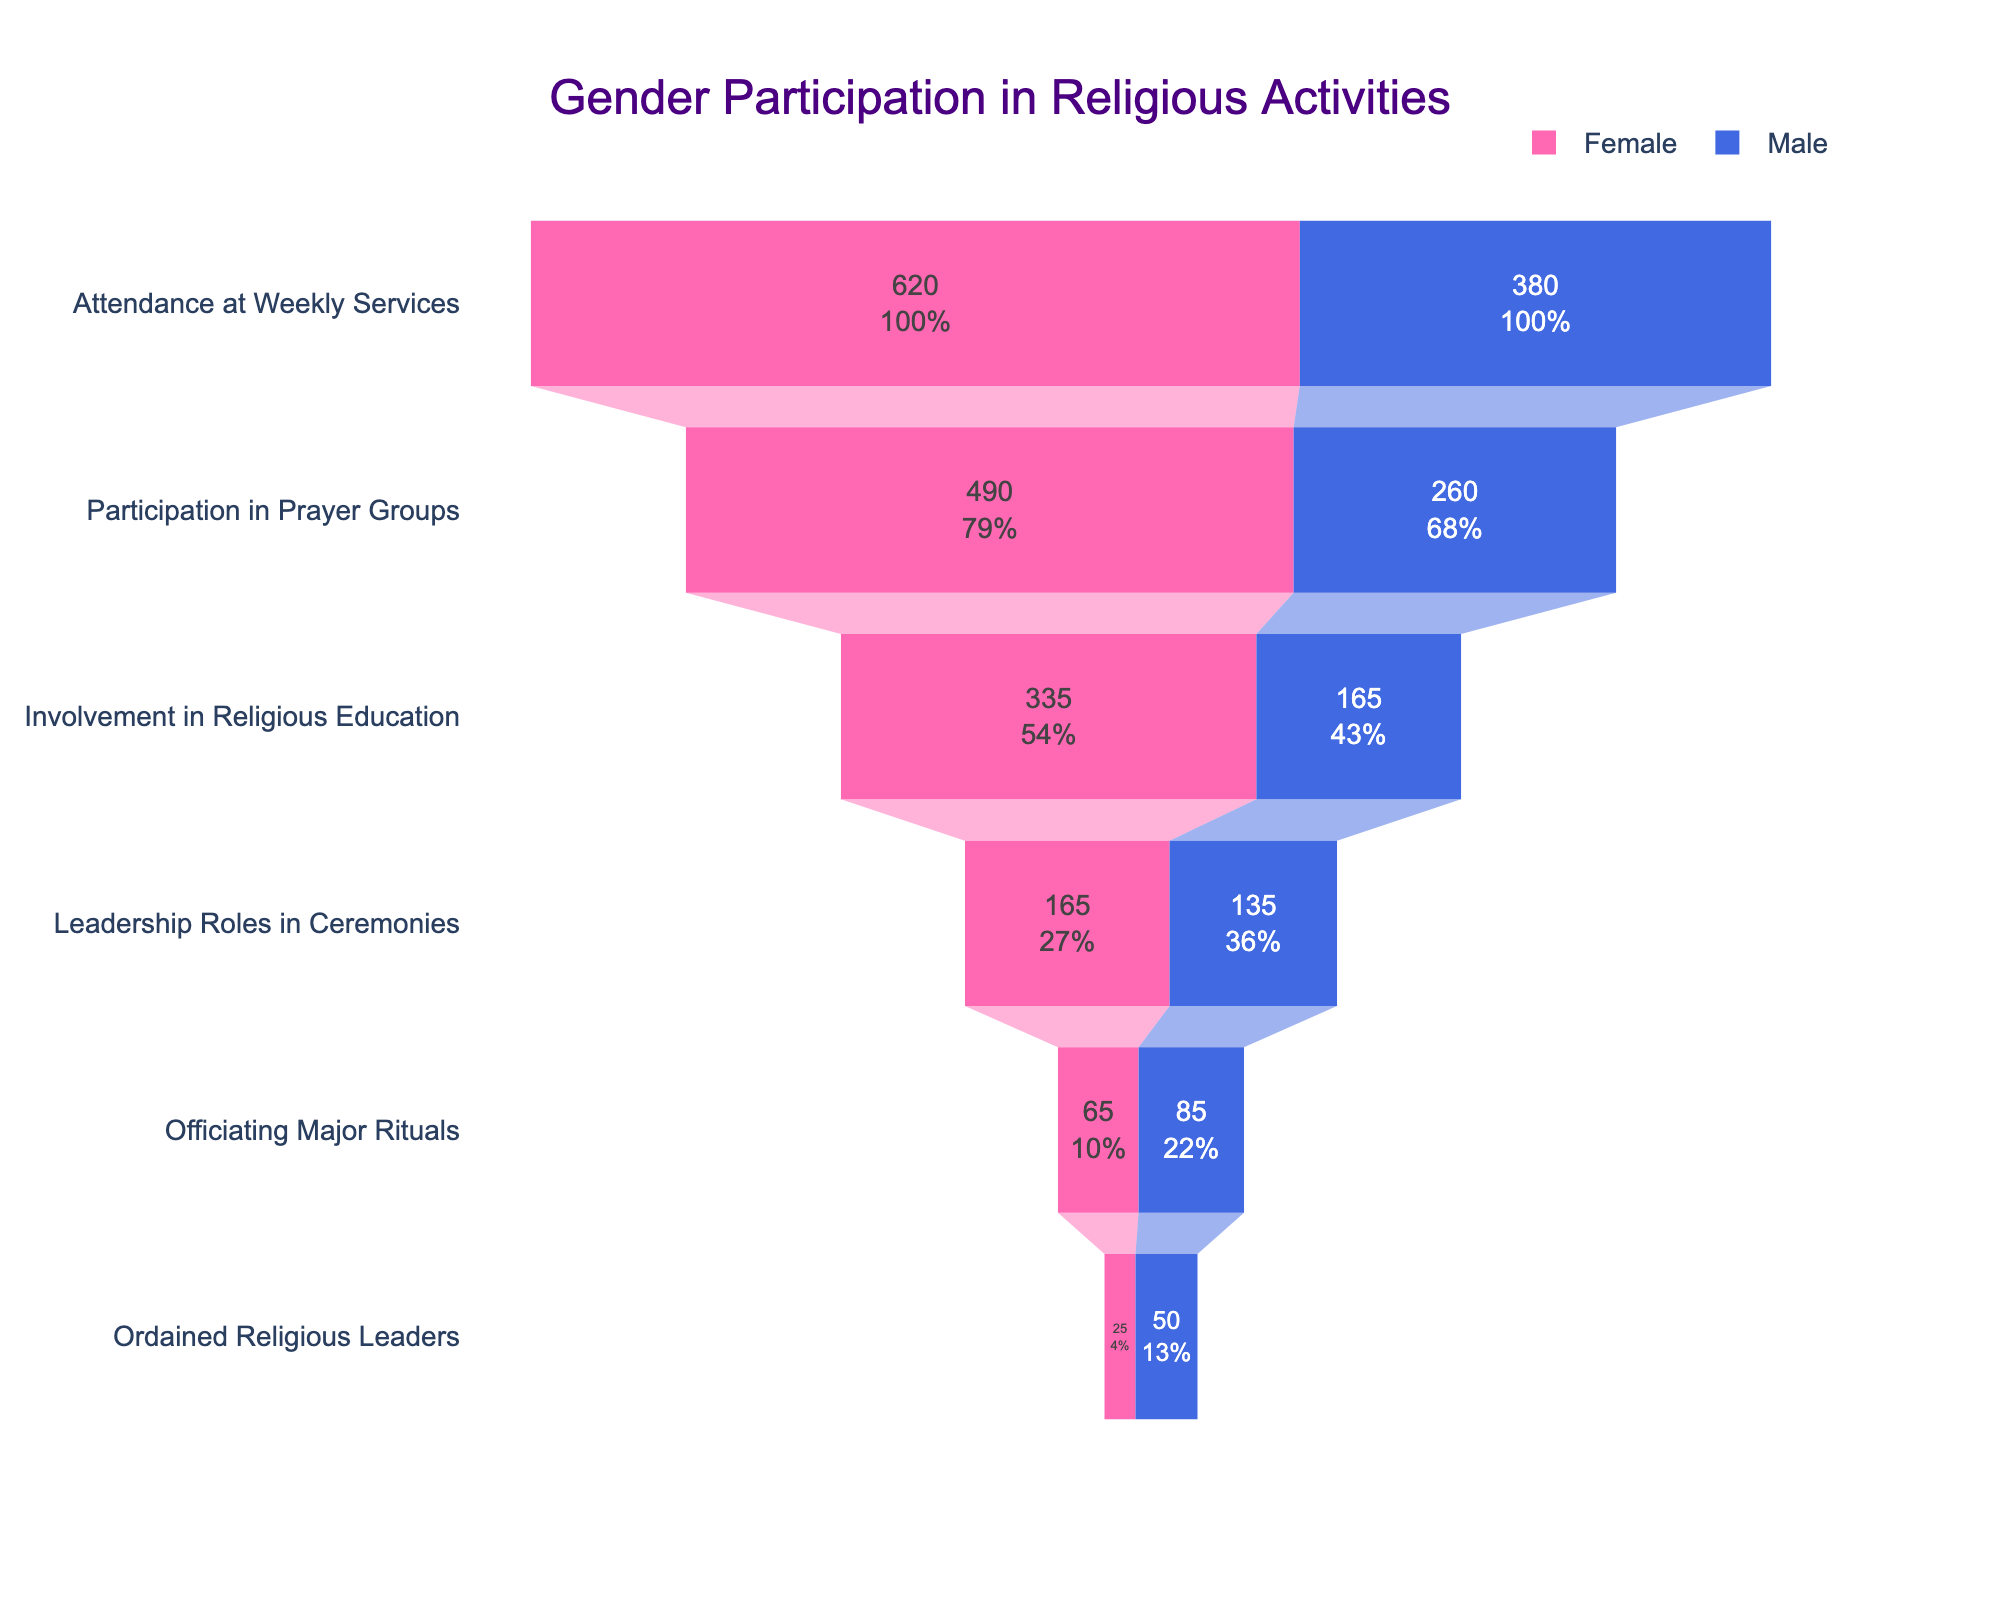What is the title of the funnel chart? The title is displayed at the top of the funnel chart.
Answer: Gender Participation in Religious Activities What is the color used to represent Female participants in the chart? The color representing Female participants is shown in the chart legend.
Answer: Pink What is the value for Female participation in Leadership Roles in Ceremonies? The value is displayed within the chart for the stage "Leadership Roles in Ceremonies".
Answer: 165 What is the difference between Female and Male participation in Officiating Major Rituals? Subtract the number of Female participants from the number of Male participants in the stage "Officiating Major Rituals" (85-65).
Answer: 20 How does Female participation in Ordained Religious Leaders compare to Male participation in the same category? Compare the number of Female participants to the number of Male participants in the stage "Ordained Religious Leaders".
Answer: Female participation is lower What is the trend in Female participation from Attendance at Weekly Services to Ordained Religious Leaders? Observe the values for Female participation across all the stages from the top to the bottom of the funnel.
Answer: Decreasing trend Which stage has the highest total Female participation? Compare the values of Female participants across all stages to find the highest one.
Answer: Attendance at Weekly Services What percentage of Female participants hold Leadership Roles in Ceremonies relative to total Female participation in Attendance at Weekly Services? Divide Female participants in "Leadership Roles in Ceremonies" by Female participants in "Attendance at Weekly Services" and multiply by 100 (165/620*100).
Answer: 26.61% How much higher is the female participation in Prayer Groups compared to Officiating Major Rituals? Subtract the number of Female participants in "Officiating Major Rituals" from those in "Participation in Prayer Groups" (490-65).
Answer: 425 What stage shows the smallest difference in participation between genders? Calculate the differences between Female and Male participants in all stages, and identify the smallest difference.
Answer: Leadership Roles in Ceremonies 